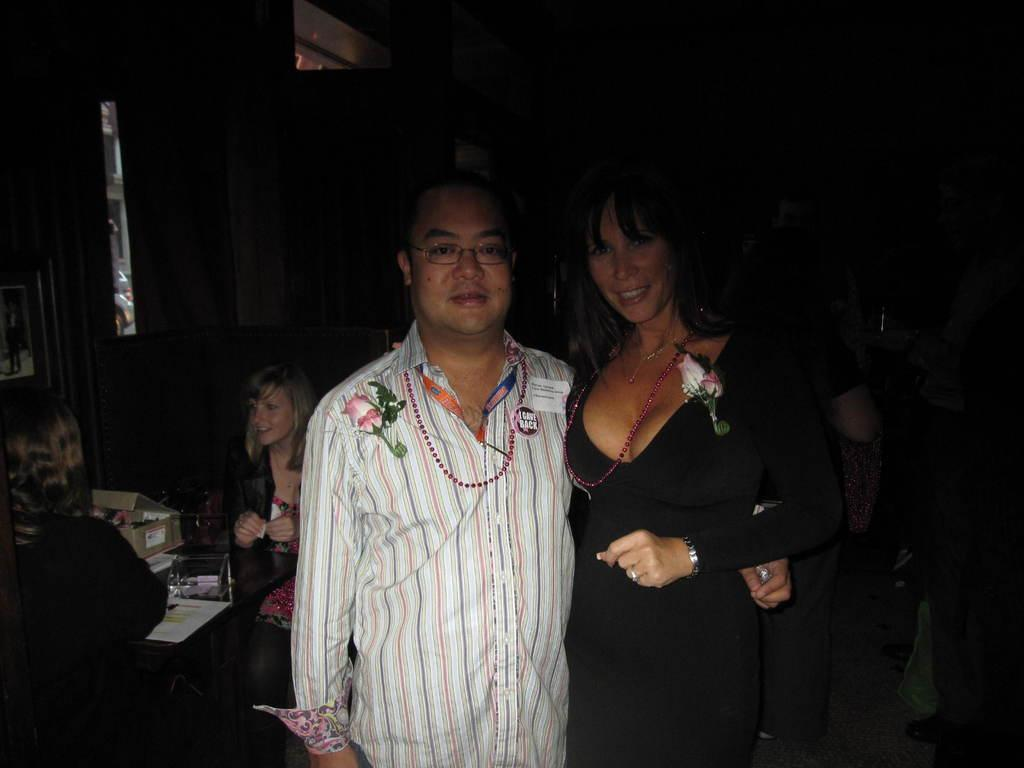What are the two persons on the right side of the image doing? The two persons on the right side of the image are in conversation. What can be seen on the left side of the image? There is a man and a lady on the left side of the image. What activity are the man and the lady engaged in? The man and the lady are clicking a photograph. What type of game is being played by the man and the lady on the left side of the image? There is no game being played in the image; the man and the lady are clicking a photograph. Can you describe the rail that is present in the image? There is no rail present in the image. 